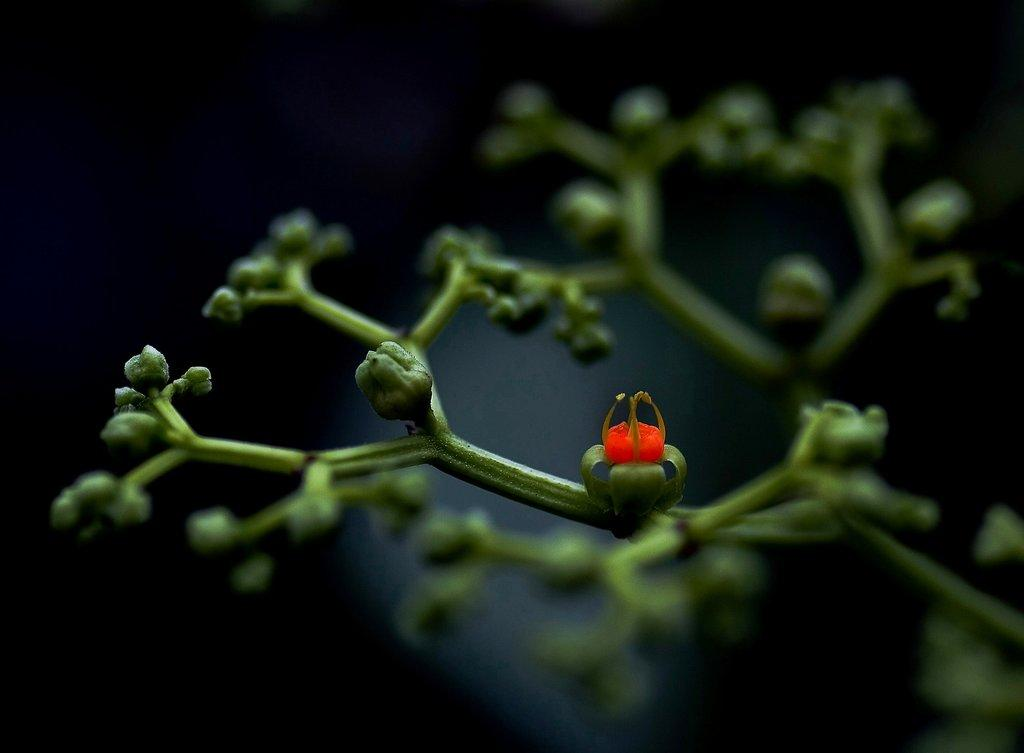What type of plant can be seen in the image? There is a flower in the image. Are there any unopened parts of the plant visible? Yes, there are buds in the image. Is the flower sinking in quicksand in the image? No, there is no quicksand present in the image, and the flower is not sinking. What type of nut is associated with the flower in the image? There is no nut associated with the flower in the image. Is there a crown on top of the flower in the image? No, there is no crown present in the image. 